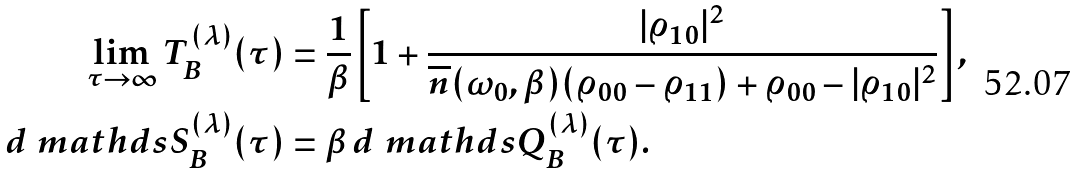Convert formula to latex. <formula><loc_0><loc_0><loc_500><loc_500>\lim _ { \tau \to \infty } T _ { B } ^ { ( \lambda ) } ( \tau ) & = \frac { 1 } { \beta } \left [ 1 + \frac { | \varrho _ { 1 0 } | ^ { 2 } } { \overline { n } ( \omega _ { 0 } , \beta ) ( \varrho _ { 0 0 } - \varrho _ { 1 1 } ) + \varrho _ { 0 0 } - | \varrho _ { 1 0 } | ^ { 2 } } \right ] , \\ d \ m a t h d s { S } ^ { ( \lambda ) } _ { B } ( \tau ) & = \beta \, d \ m a t h d s { Q } ^ { ( \lambda ) } _ { B } ( \tau ) .</formula> 